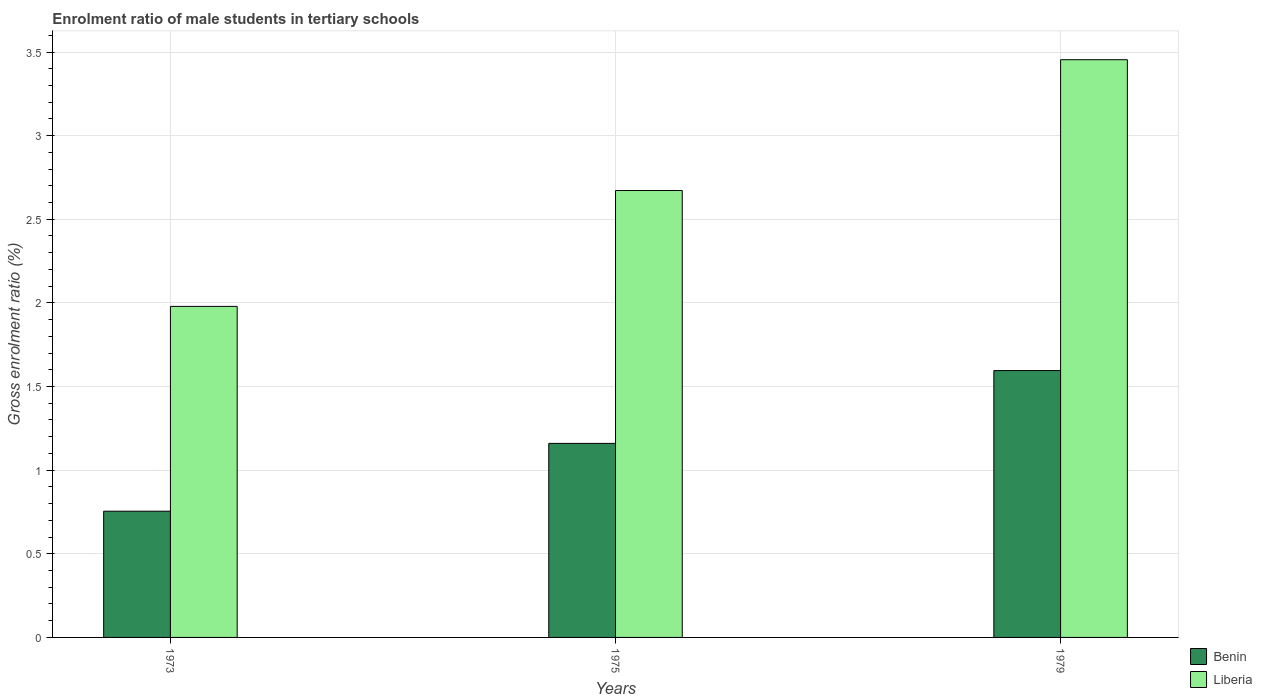How many different coloured bars are there?
Offer a very short reply. 2. How many groups of bars are there?
Your answer should be compact. 3. Are the number of bars on each tick of the X-axis equal?
Your answer should be compact. Yes. How many bars are there on the 2nd tick from the left?
Provide a succinct answer. 2. What is the label of the 2nd group of bars from the left?
Ensure brevity in your answer.  1975. What is the enrolment ratio of male students in tertiary schools in Liberia in 1975?
Provide a short and direct response. 2.67. Across all years, what is the maximum enrolment ratio of male students in tertiary schools in Benin?
Your response must be concise. 1.6. Across all years, what is the minimum enrolment ratio of male students in tertiary schools in Liberia?
Make the answer very short. 1.98. In which year was the enrolment ratio of male students in tertiary schools in Liberia maximum?
Keep it short and to the point. 1979. What is the total enrolment ratio of male students in tertiary schools in Liberia in the graph?
Provide a succinct answer. 8.11. What is the difference between the enrolment ratio of male students in tertiary schools in Benin in 1975 and that in 1979?
Give a very brief answer. -0.44. What is the difference between the enrolment ratio of male students in tertiary schools in Benin in 1975 and the enrolment ratio of male students in tertiary schools in Liberia in 1973?
Your response must be concise. -0.82. What is the average enrolment ratio of male students in tertiary schools in Liberia per year?
Make the answer very short. 2.7. In the year 1973, what is the difference between the enrolment ratio of male students in tertiary schools in Benin and enrolment ratio of male students in tertiary schools in Liberia?
Provide a succinct answer. -1.22. What is the ratio of the enrolment ratio of male students in tertiary schools in Benin in 1973 to that in 1979?
Offer a very short reply. 0.47. Is the enrolment ratio of male students in tertiary schools in Liberia in 1973 less than that in 1975?
Provide a short and direct response. Yes. What is the difference between the highest and the second highest enrolment ratio of male students in tertiary schools in Benin?
Provide a succinct answer. 0.44. What is the difference between the highest and the lowest enrolment ratio of male students in tertiary schools in Liberia?
Provide a short and direct response. 1.47. Is the sum of the enrolment ratio of male students in tertiary schools in Benin in 1973 and 1979 greater than the maximum enrolment ratio of male students in tertiary schools in Liberia across all years?
Offer a terse response. No. What does the 1st bar from the left in 1979 represents?
Offer a terse response. Benin. What does the 1st bar from the right in 1979 represents?
Make the answer very short. Liberia. How many bars are there?
Provide a short and direct response. 6. How many years are there in the graph?
Your response must be concise. 3. Does the graph contain any zero values?
Your answer should be compact. No. What is the title of the graph?
Your response must be concise. Enrolment ratio of male students in tertiary schools. Does "Estonia" appear as one of the legend labels in the graph?
Your response must be concise. No. What is the Gross enrolment ratio (%) of Benin in 1973?
Your answer should be very brief. 0.75. What is the Gross enrolment ratio (%) in Liberia in 1973?
Make the answer very short. 1.98. What is the Gross enrolment ratio (%) in Benin in 1975?
Your response must be concise. 1.16. What is the Gross enrolment ratio (%) in Liberia in 1975?
Give a very brief answer. 2.67. What is the Gross enrolment ratio (%) in Benin in 1979?
Provide a succinct answer. 1.6. What is the Gross enrolment ratio (%) in Liberia in 1979?
Offer a terse response. 3.45. Across all years, what is the maximum Gross enrolment ratio (%) in Benin?
Keep it short and to the point. 1.6. Across all years, what is the maximum Gross enrolment ratio (%) in Liberia?
Your answer should be very brief. 3.45. Across all years, what is the minimum Gross enrolment ratio (%) of Benin?
Make the answer very short. 0.75. Across all years, what is the minimum Gross enrolment ratio (%) in Liberia?
Your answer should be very brief. 1.98. What is the total Gross enrolment ratio (%) of Benin in the graph?
Provide a succinct answer. 3.51. What is the total Gross enrolment ratio (%) of Liberia in the graph?
Your answer should be very brief. 8.11. What is the difference between the Gross enrolment ratio (%) in Benin in 1973 and that in 1975?
Provide a succinct answer. -0.41. What is the difference between the Gross enrolment ratio (%) of Liberia in 1973 and that in 1975?
Give a very brief answer. -0.69. What is the difference between the Gross enrolment ratio (%) in Benin in 1973 and that in 1979?
Your answer should be compact. -0.84. What is the difference between the Gross enrolment ratio (%) in Liberia in 1973 and that in 1979?
Your response must be concise. -1.47. What is the difference between the Gross enrolment ratio (%) in Benin in 1975 and that in 1979?
Ensure brevity in your answer.  -0.44. What is the difference between the Gross enrolment ratio (%) in Liberia in 1975 and that in 1979?
Your answer should be compact. -0.78. What is the difference between the Gross enrolment ratio (%) in Benin in 1973 and the Gross enrolment ratio (%) in Liberia in 1975?
Offer a terse response. -1.92. What is the difference between the Gross enrolment ratio (%) of Benin in 1973 and the Gross enrolment ratio (%) of Liberia in 1979?
Your answer should be very brief. -2.7. What is the difference between the Gross enrolment ratio (%) in Benin in 1975 and the Gross enrolment ratio (%) in Liberia in 1979?
Make the answer very short. -2.29. What is the average Gross enrolment ratio (%) in Benin per year?
Provide a succinct answer. 1.17. What is the average Gross enrolment ratio (%) of Liberia per year?
Your answer should be very brief. 2.7. In the year 1973, what is the difference between the Gross enrolment ratio (%) of Benin and Gross enrolment ratio (%) of Liberia?
Your answer should be compact. -1.22. In the year 1975, what is the difference between the Gross enrolment ratio (%) of Benin and Gross enrolment ratio (%) of Liberia?
Provide a succinct answer. -1.51. In the year 1979, what is the difference between the Gross enrolment ratio (%) of Benin and Gross enrolment ratio (%) of Liberia?
Provide a short and direct response. -1.86. What is the ratio of the Gross enrolment ratio (%) in Benin in 1973 to that in 1975?
Provide a succinct answer. 0.65. What is the ratio of the Gross enrolment ratio (%) in Liberia in 1973 to that in 1975?
Keep it short and to the point. 0.74. What is the ratio of the Gross enrolment ratio (%) in Benin in 1973 to that in 1979?
Offer a terse response. 0.47. What is the ratio of the Gross enrolment ratio (%) of Liberia in 1973 to that in 1979?
Keep it short and to the point. 0.57. What is the ratio of the Gross enrolment ratio (%) of Benin in 1975 to that in 1979?
Give a very brief answer. 0.73. What is the ratio of the Gross enrolment ratio (%) in Liberia in 1975 to that in 1979?
Your answer should be very brief. 0.77. What is the difference between the highest and the second highest Gross enrolment ratio (%) of Benin?
Provide a short and direct response. 0.44. What is the difference between the highest and the second highest Gross enrolment ratio (%) of Liberia?
Offer a very short reply. 0.78. What is the difference between the highest and the lowest Gross enrolment ratio (%) in Benin?
Your answer should be compact. 0.84. What is the difference between the highest and the lowest Gross enrolment ratio (%) of Liberia?
Provide a short and direct response. 1.47. 